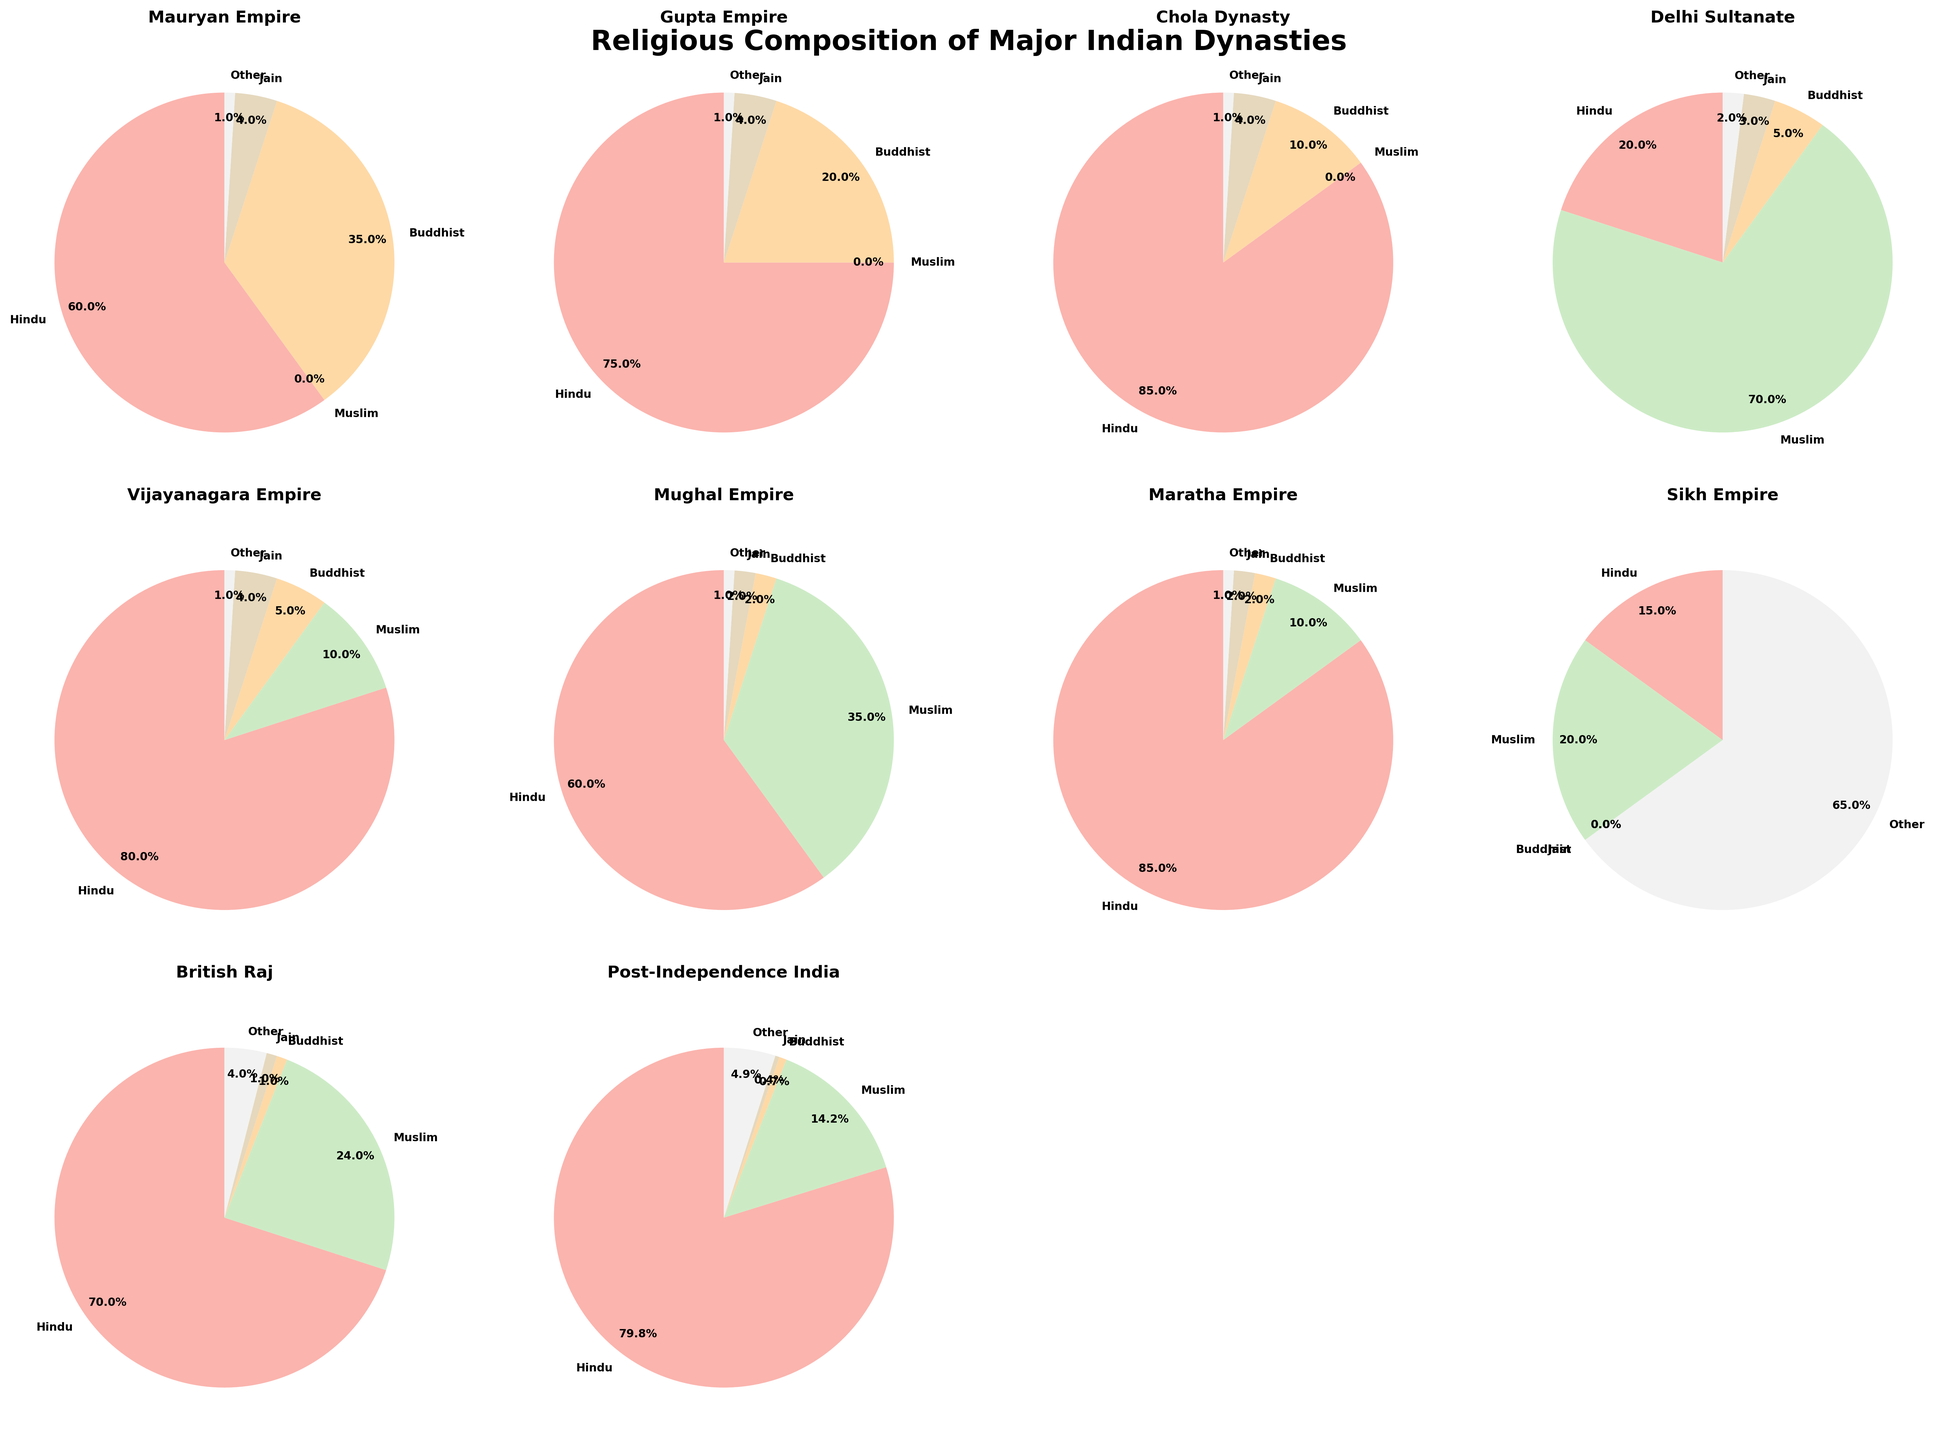What dynasty has the highest proportion of Hinduism? To determine the dynasty with the highest proportion of Hinduism, we compare the percentage values in the "Hindu" section of each pie chart. The Maratha Empire has 85%, which is the highest.
Answer: Maratha Empire What is the difference in the proportion of Buddhism between the Mauryan Empire and Gupta Empire? Calculate the proportion of Buddhism for both empires: Mauryan Empire (35%) and Gupta Empire (20%). The difference is 35% - 20% = 15%.
Answer: 15% Which dynasties have a Muslim population greater than or equal to 20%? Identify and list dynasties where the Muslim proportion is 20% or higher. According to the charts, these are the Delhi Sultanate (70%), Mughal Empire (35%), Sikh Empire (20%), and British Raj (24%).
Answer: Delhi Sultanate, Mughal Empire, Sikh Empire, British Raj How does the religious composition of the Chola Dynasty compare to the Vijayanagara Empire in terms of Jainism? Look at the Jainism percentage in both dynasties. The Chola Dynasty has 4% Jainism, and so does the Vijayanagara Empire.
Answer: Equal Which dynasty has the largest "Other" religious composition? By examining the "Other" segment in each pie chart, the Sikh Empire has the largest "Other" religious composition with a proportion of 65%.
Answer: Sikh Empire Compare the proportion of Hinduism in the British Raj and Post-Independence India. Which one is higher and by how much? Hindu proportions are 70% in the British Raj and 79.8% in Post-Independence India. Therefore, 79.8% - 70% = 9.8%. Post-Independence India has a 9.8% higher proportion of Hinduism.
Answer: Post-Independence India by 9.8% What is the total proportion of non-Muslims in the Mughal Empire? Summing up the percentages for Hindu, Buddhist, Jain, and Other: 60% + 2% + 2% + 1% = 65%.
Answer: 65% Which dynasty had a unique religious composition with a dominant "Other" religion, and what was it? The pie chart for the Sikh Empire shows a 65% "Other" religion, mainly Sikhism, making it unique.
Answer: Sikh Empire Between the Mauryan Empire and the Gupta Empire, which one had a higher Buddhist population and by how much? The Mauryan Empire had 35% Buddhism, whereas the Gupta Empire had 20%. The difference is 35% - 20% = 15%.
Answer: Mauryan Empire by 15% Which dynasty shows a near-equal representation between Muslims and Hindus? Checking the charts, the Mughal Empire has 60% Hindu and 35% Muslim populations, which are relatively balanced in comparison with other emperors, though not entirely equal.
Answer: Mughal Empire 